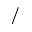Convert formula to latex. <formula><loc_0><loc_0><loc_500><loc_500>/</formula> 